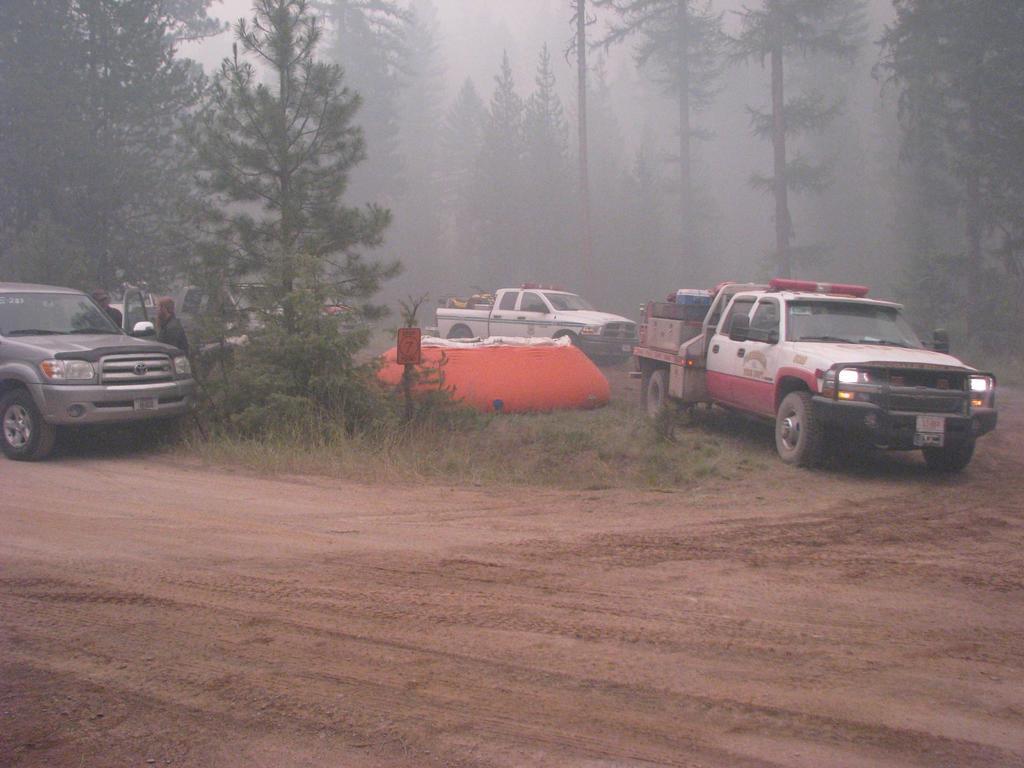Could you give a brief overview of what you see in this image? In this image I can see few vehicles, few people, number of trees and fog. I can also see grass and an orange colour thing in the centre. 